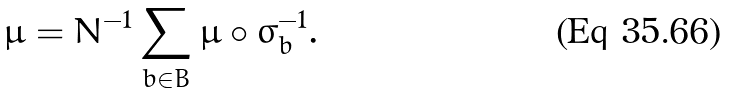<formula> <loc_0><loc_0><loc_500><loc_500>\mu = N ^ { - 1 } \sum _ { b \in B } \mu \circ \sigma _ { b } ^ { - 1 } .</formula> 